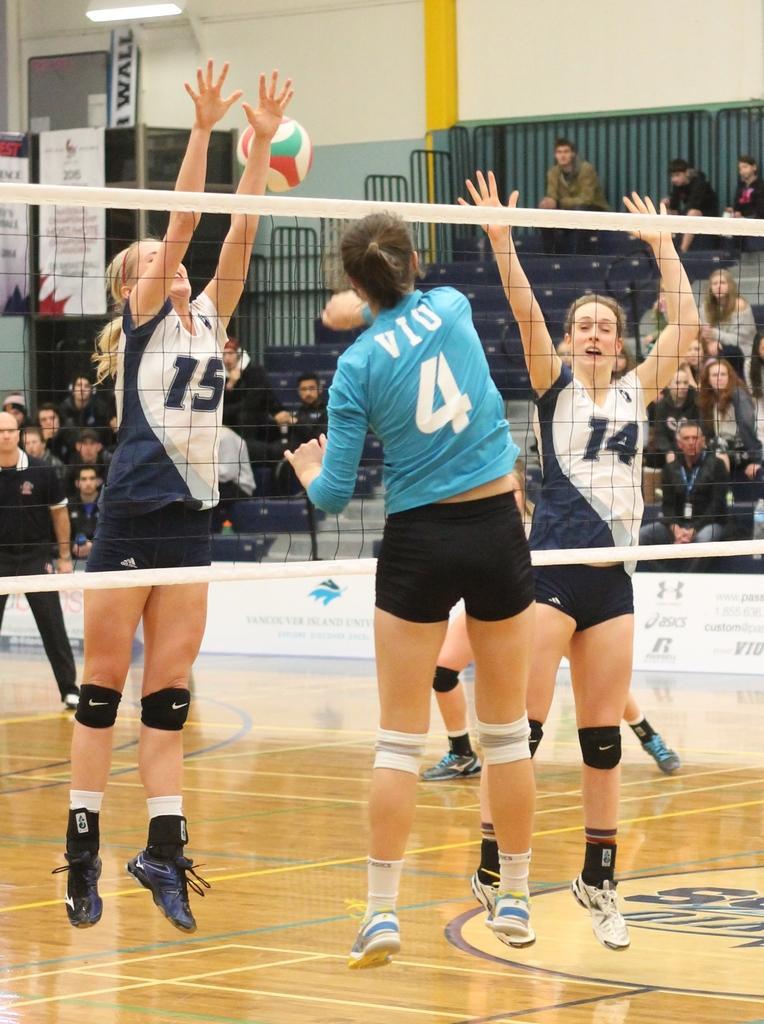Can you describe this image briefly? As we can see in the image there are few people here and there, a football, net, banner and wall. 